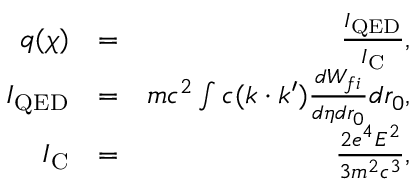<formula> <loc_0><loc_0><loc_500><loc_500>\begin{array} { r l r } { q ( \chi ) } & { = } & { \frac { I _ { Q E D } } { I _ { C } } , } \\ { I _ { Q E D } } & { = } & { m c ^ { 2 } \int c ( k \cdot k ^ { \prime } ) \frac { d W _ { f i } } { d \eta d r _ { 0 } } d r _ { 0 } , } \\ { I _ { C } } & { = } & { \frac { 2 e ^ { 4 } E ^ { 2 } } { 3 m ^ { 2 } c ^ { 3 } } , } \end{array}</formula> 